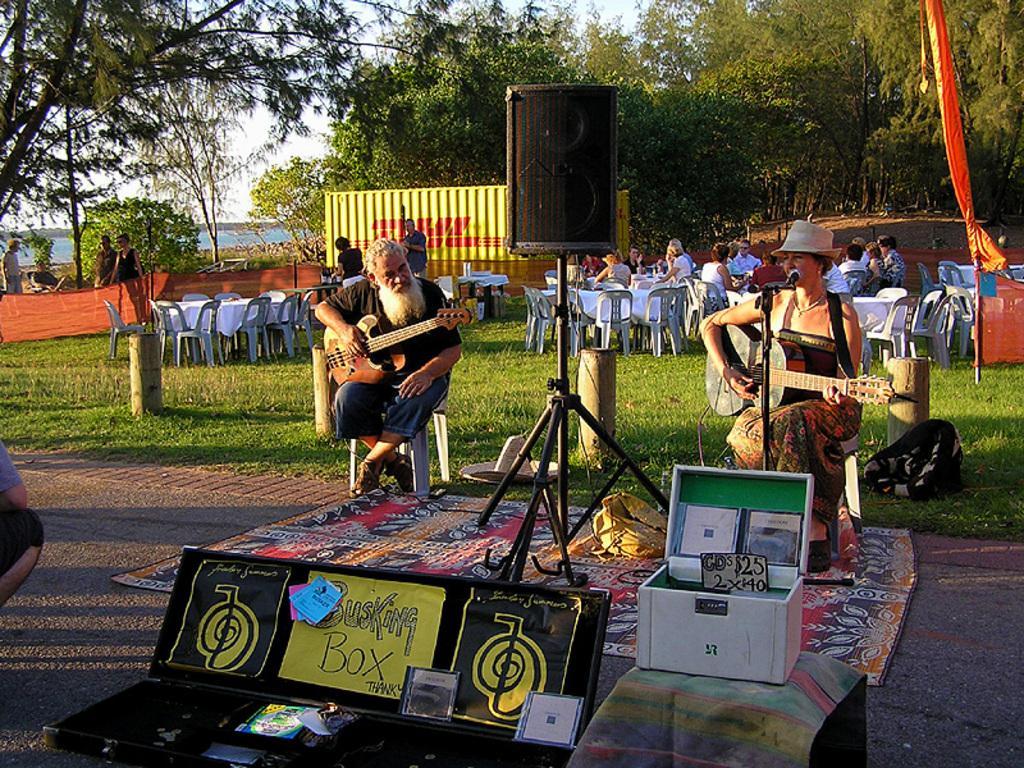How would you summarize this image in a sentence or two? At the top there is a sky. These are trees. We can see persons standing and walking on the grass. We can see all the persons sitting on chairs. Here on the platform we can see a women and a man sitting on the chairs and playing guitars. This is a speaker. This is a mat. Here we can see boxes. 